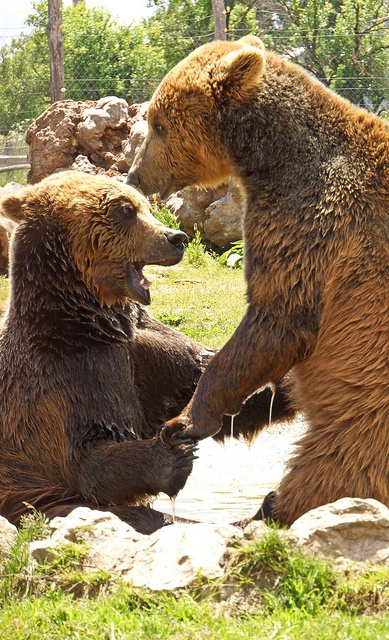Describe the objects in this image and their specific colors. I can see bear in white, maroon, brown, and black tones and bear in white, black, maroon, and gray tones in this image. 